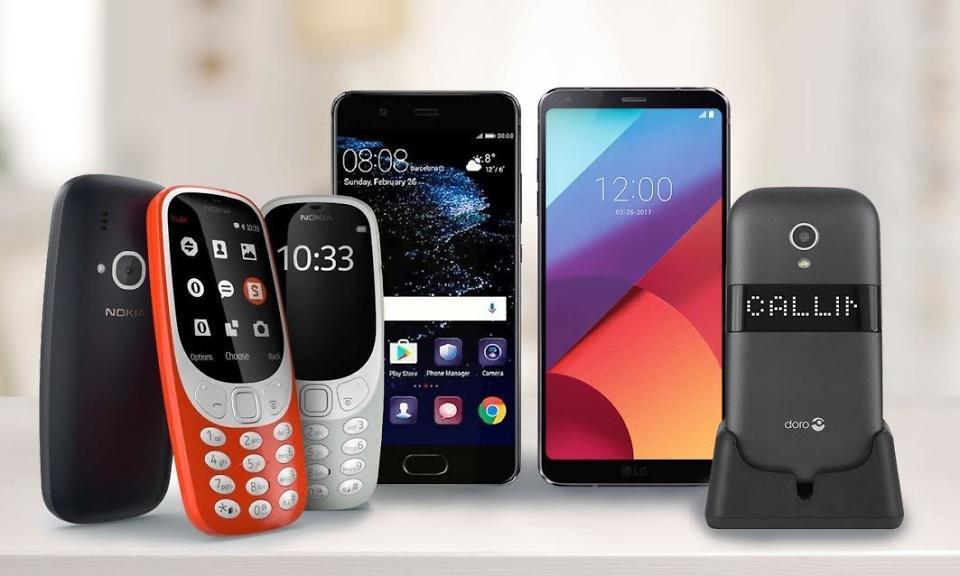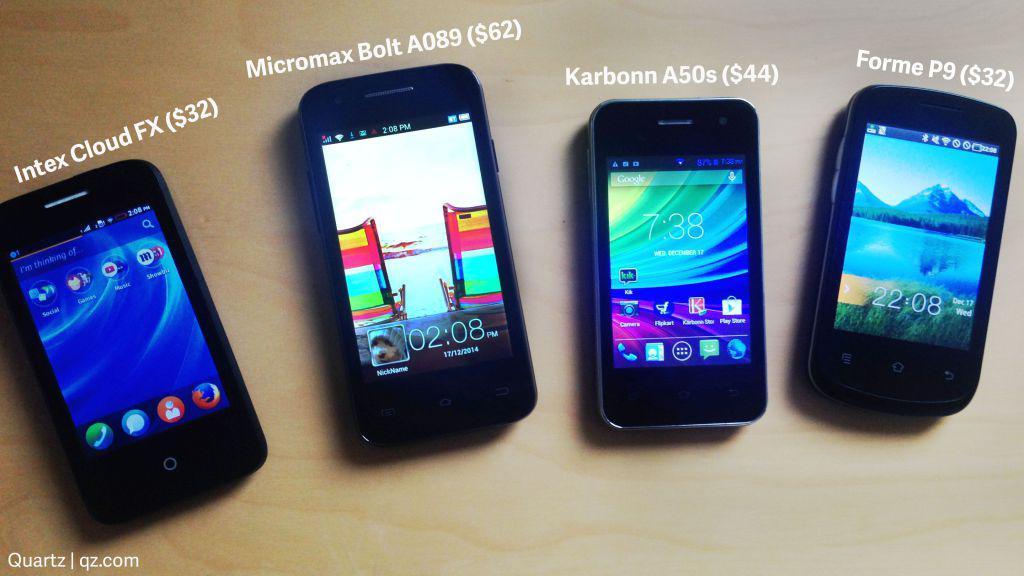The first image is the image on the left, the second image is the image on the right. Evaluate the accuracy of this statement regarding the images: "Every image shows at least four devices and all screens show an image.". Is it true? Answer yes or no. Yes. The first image is the image on the left, the second image is the image on the right. Examine the images to the left and right. Is the description "One image contains exactly four phones, and the other image contains at least five phones." accurate? Answer yes or no. Yes. 